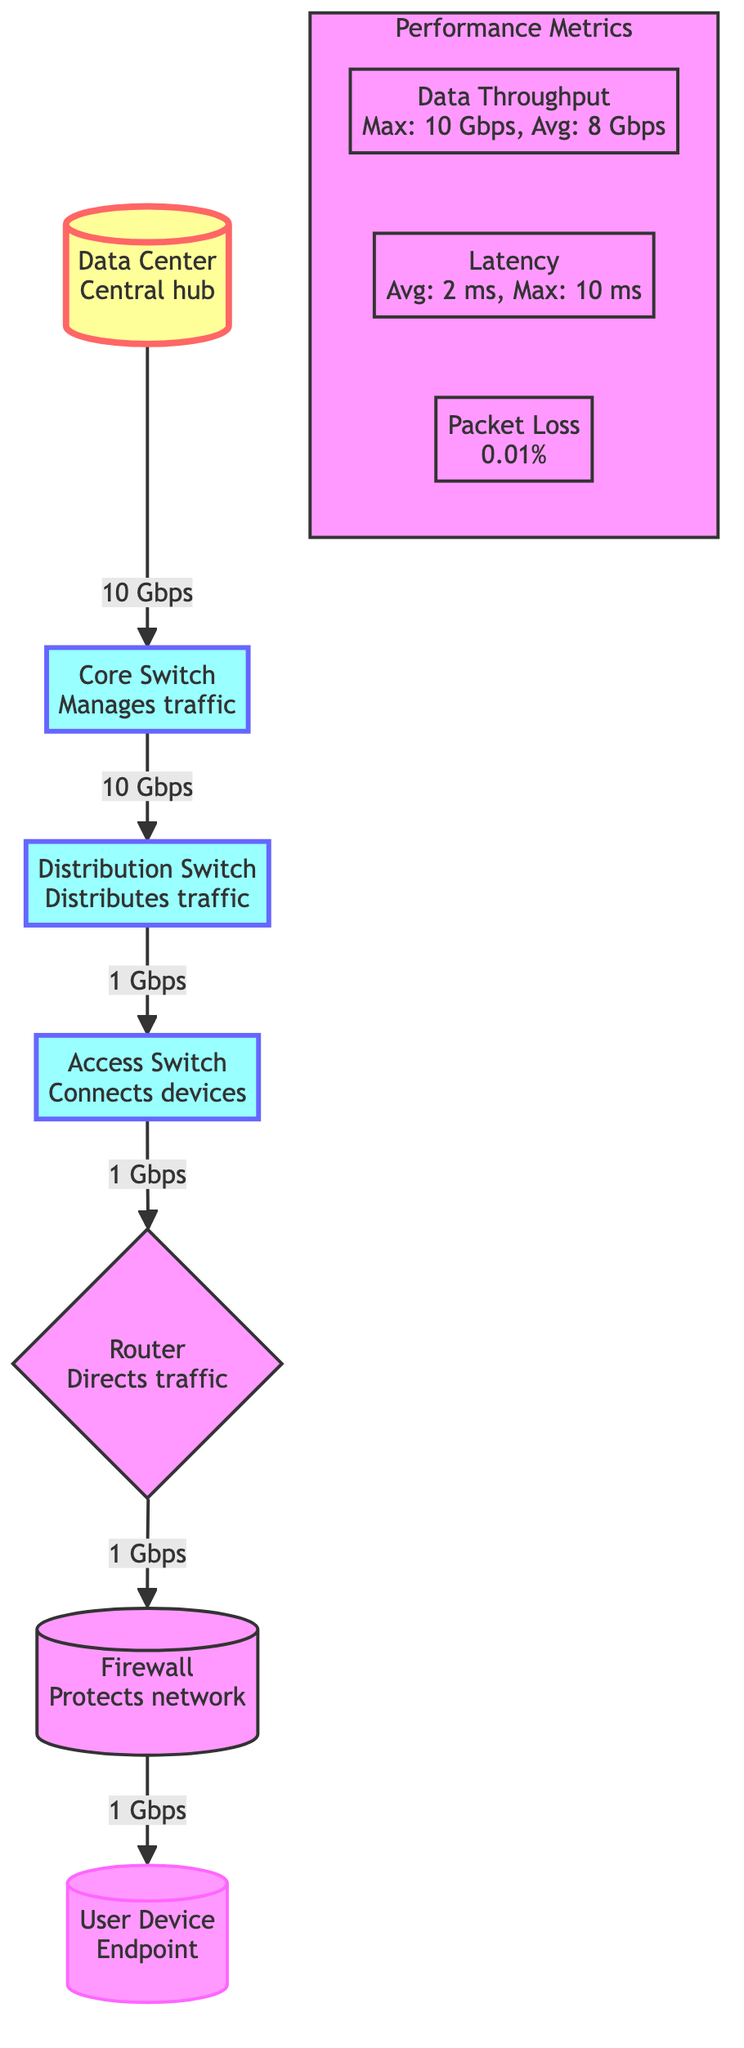What is the average data throughput? The diagram shows a performance metric labeled "Data Throughput" with an average value specified. By reading the information presented, the average data throughput value of "8 Gbps" is identified.
Answer: 8 Gbps What connects the user device to the firewall? The diagram indicates a direct line from "User Device" to the "Firewall". This relationship shows the established link where the user device routes through the firewall for network security.
Answer: Firewall How many switches are present in the diagram? Looking at the network components, we see three different types of switches listed: Core Switch, Distribution Switch, and Access Switch. Thus, we count a total of three switches present in the diagram.
Answer: 3 What is the maximum latency as indicated in the performance metrics? Within the "Latency" performance metric in the diagram, the maximum latency is explicitly stated as "10 ms". This value can be easily located within the performance metrics group.
Answer: 10 ms What is the let pass percentage of packet loss? The performance metric for "Packet Loss" directly shows a value of "0.01%". This percentage reflects the proportion of packets that were lost during transmission.
Answer: 0.01% Which component manages the traffic in the network architecture? According to the labels in the diagram, the "Core Switch" is explicitly noted to "Manage traffic". This indicates its central role in directing and controlling network traffic.
Answer: Core Switch What is the data rate from the distribution switch to the access switch? The diagram illustrates an arrow from the "Distribution Switch" to the "Access Switch," accompanied by the label "1 Gbps." This indicates the data rate at which the distribution switch sends data to the access switch.
Answer: 1 Gbps What is the role of the router in the network diagram? The diagram identifies the "Router" with the role of "Directs traffic," which indicates its key function within the network to route data between different network segments.
Answer: Directs traffic How many nodes are in the primary stage of the network architecture? Analyzing the diagram, there are two main nodes in the network architecture's primary stage: "Data Center" and "Core Switch". Thus, the total can be counted as two nodes.
Answer: 2 